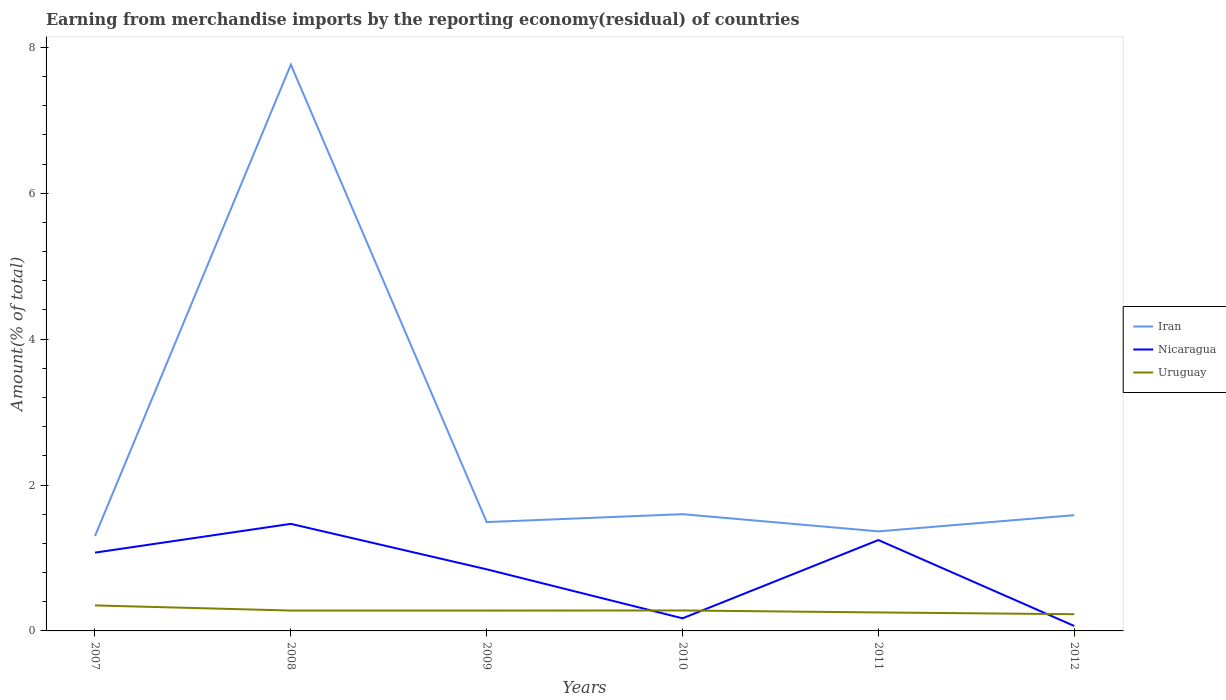Does the line corresponding to Uruguay intersect with the line corresponding to Iran?
Offer a terse response. No. Is the number of lines equal to the number of legend labels?
Your answer should be very brief. Yes. Across all years, what is the maximum percentage of amount earned from merchandise imports in Iran?
Your answer should be compact. 1.3. What is the total percentage of amount earned from merchandise imports in Iran in the graph?
Your answer should be very brief. -0.06. What is the difference between the highest and the second highest percentage of amount earned from merchandise imports in Iran?
Give a very brief answer. 6.46. What is the difference between the highest and the lowest percentage of amount earned from merchandise imports in Uruguay?
Provide a succinct answer. 4. How many lines are there?
Offer a terse response. 3. How many years are there in the graph?
Your answer should be very brief. 6. Does the graph contain any zero values?
Keep it short and to the point. No. Does the graph contain grids?
Provide a succinct answer. No. Where does the legend appear in the graph?
Your answer should be very brief. Center right. What is the title of the graph?
Offer a very short reply. Earning from merchandise imports by the reporting economy(residual) of countries. What is the label or title of the X-axis?
Your answer should be very brief. Years. What is the label or title of the Y-axis?
Make the answer very short. Amount(% of total). What is the Amount(% of total) in Iran in 2007?
Give a very brief answer. 1.3. What is the Amount(% of total) in Nicaragua in 2007?
Offer a very short reply. 1.07. What is the Amount(% of total) in Uruguay in 2007?
Ensure brevity in your answer.  0.35. What is the Amount(% of total) in Iran in 2008?
Make the answer very short. 7.76. What is the Amount(% of total) in Nicaragua in 2008?
Give a very brief answer. 1.47. What is the Amount(% of total) of Uruguay in 2008?
Ensure brevity in your answer.  0.28. What is the Amount(% of total) of Iran in 2009?
Ensure brevity in your answer.  1.49. What is the Amount(% of total) of Nicaragua in 2009?
Ensure brevity in your answer.  0.84. What is the Amount(% of total) in Uruguay in 2009?
Offer a very short reply. 0.28. What is the Amount(% of total) in Iran in 2010?
Your response must be concise. 1.6. What is the Amount(% of total) in Nicaragua in 2010?
Your answer should be compact. 0.17. What is the Amount(% of total) of Uruguay in 2010?
Offer a very short reply. 0.28. What is the Amount(% of total) of Iran in 2011?
Your response must be concise. 1.36. What is the Amount(% of total) in Nicaragua in 2011?
Ensure brevity in your answer.  1.25. What is the Amount(% of total) of Uruguay in 2011?
Your answer should be compact. 0.25. What is the Amount(% of total) in Iran in 2012?
Provide a short and direct response. 1.59. What is the Amount(% of total) in Nicaragua in 2012?
Offer a terse response. 0.07. What is the Amount(% of total) of Uruguay in 2012?
Ensure brevity in your answer.  0.23. Across all years, what is the maximum Amount(% of total) in Iran?
Keep it short and to the point. 7.76. Across all years, what is the maximum Amount(% of total) of Nicaragua?
Give a very brief answer. 1.47. Across all years, what is the maximum Amount(% of total) in Uruguay?
Provide a succinct answer. 0.35. Across all years, what is the minimum Amount(% of total) in Iran?
Your answer should be very brief. 1.3. Across all years, what is the minimum Amount(% of total) in Nicaragua?
Provide a short and direct response. 0.07. Across all years, what is the minimum Amount(% of total) of Uruguay?
Ensure brevity in your answer.  0.23. What is the total Amount(% of total) in Iran in the graph?
Offer a terse response. 15.11. What is the total Amount(% of total) in Nicaragua in the graph?
Provide a succinct answer. 4.87. What is the total Amount(% of total) of Uruguay in the graph?
Keep it short and to the point. 1.67. What is the difference between the Amount(% of total) of Iran in 2007 and that in 2008?
Offer a terse response. -6.46. What is the difference between the Amount(% of total) in Nicaragua in 2007 and that in 2008?
Provide a short and direct response. -0.39. What is the difference between the Amount(% of total) of Uruguay in 2007 and that in 2008?
Offer a terse response. 0.07. What is the difference between the Amount(% of total) of Iran in 2007 and that in 2009?
Offer a very short reply. -0.19. What is the difference between the Amount(% of total) in Nicaragua in 2007 and that in 2009?
Offer a terse response. 0.23. What is the difference between the Amount(% of total) in Uruguay in 2007 and that in 2009?
Make the answer very short. 0.07. What is the difference between the Amount(% of total) of Iran in 2007 and that in 2010?
Your answer should be very brief. -0.3. What is the difference between the Amount(% of total) in Nicaragua in 2007 and that in 2010?
Keep it short and to the point. 0.9. What is the difference between the Amount(% of total) of Uruguay in 2007 and that in 2010?
Provide a succinct answer. 0.07. What is the difference between the Amount(% of total) in Iran in 2007 and that in 2011?
Your response must be concise. -0.06. What is the difference between the Amount(% of total) in Nicaragua in 2007 and that in 2011?
Provide a short and direct response. -0.17. What is the difference between the Amount(% of total) of Uruguay in 2007 and that in 2011?
Offer a terse response. 0.1. What is the difference between the Amount(% of total) in Iran in 2007 and that in 2012?
Your answer should be very brief. -0.29. What is the difference between the Amount(% of total) of Nicaragua in 2007 and that in 2012?
Your answer should be very brief. 1.01. What is the difference between the Amount(% of total) in Uruguay in 2007 and that in 2012?
Ensure brevity in your answer.  0.12. What is the difference between the Amount(% of total) in Iran in 2008 and that in 2009?
Provide a succinct answer. 6.27. What is the difference between the Amount(% of total) in Nicaragua in 2008 and that in 2009?
Your answer should be very brief. 0.62. What is the difference between the Amount(% of total) in Uruguay in 2008 and that in 2009?
Give a very brief answer. 0. What is the difference between the Amount(% of total) in Iran in 2008 and that in 2010?
Offer a terse response. 6.16. What is the difference between the Amount(% of total) of Nicaragua in 2008 and that in 2010?
Offer a terse response. 1.29. What is the difference between the Amount(% of total) of Uruguay in 2008 and that in 2010?
Your answer should be very brief. -0. What is the difference between the Amount(% of total) in Iran in 2008 and that in 2011?
Provide a short and direct response. 6.4. What is the difference between the Amount(% of total) in Nicaragua in 2008 and that in 2011?
Provide a short and direct response. 0.22. What is the difference between the Amount(% of total) in Uruguay in 2008 and that in 2011?
Keep it short and to the point. 0.03. What is the difference between the Amount(% of total) in Iran in 2008 and that in 2012?
Offer a terse response. 6.18. What is the difference between the Amount(% of total) in Nicaragua in 2008 and that in 2012?
Make the answer very short. 1.4. What is the difference between the Amount(% of total) of Uruguay in 2008 and that in 2012?
Provide a short and direct response. 0.05. What is the difference between the Amount(% of total) of Iran in 2009 and that in 2010?
Keep it short and to the point. -0.11. What is the difference between the Amount(% of total) of Nicaragua in 2009 and that in 2010?
Your answer should be very brief. 0.67. What is the difference between the Amount(% of total) in Uruguay in 2009 and that in 2010?
Your answer should be compact. -0. What is the difference between the Amount(% of total) in Iran in 2009 and that in 2011?
Your answer should be compact. 0.13. What is the difference between the Amount(% of total) of Nicaragua in 2009 and that in 2011?
Offer a terse response. -0.4. What is the difference between the Amount(% of total) in Uruguay in 2009 and that in 2011?
Offer a very short reply. 0.03. What is the difference between the Amount(% of total) in Iran in 2009 and that in 2012?
Offer a terse response. -0.09. What is the difference between the Amount(% of total) of Nicaragua in 2009 and that in 2012?
Your answer should be very brief. 0.78. What is the difference between the Amount(% of total) in Uruguay in 2009 and that in 2012?
Ensure brevity in your answer.  0.05. What is the difference between the Amount(% of total) of Iran in 2010 and that in 2011?
Your answer should be compact. 0.24. What is the difference between the Amount(% of total) in Nicaragua in 2010 and that in 2011?
Ensure brevity in your answer.  -1.07. What is the difference between the Amount(% of total) of Uruguay in 2010 and that in 2011?
Keep it short and to the point. 0.03. What is the difference between the Amount(% of total) of Iran in 2010 and that in 2012?
Provide a succinct answer. 0.01. What is the difference between the Amount(% of total) in Nicaragua in 2010 and that in 2012?
Keep it short and to the point. 0.1. What is the difference between the Amount(% of total) in Uruguay in 2010 and that in 2012?
Your response must be concise. 0.05. What is the difference between the Amount(% of total) of Iran in 2011 and that in 2012?
Ensure brevity in your answer.  -0.22. What is the difference between the Amount(% of total) in Nicaragua in 2011 and that in 2012?
Make the answer very short. 1.18. What is the difference between the Amount(% of total) of Uruguay in 2011 and that in 2012?
Your response must be concise. 0.02. What is the difference between the Amount(% of total) in Iran in 2007 and the Amount(% of total) in Nicaragua in 2008?
Keep it short and to the point. -0.17. What is the difference between the Amount(% of total) in Iran in 2007 and the Amount(% of total) in Uruguay in 2008?
Give a very brief answer. 1.02. What is the difference between the Amount(% of total) in Nicaragua in 2007 and the Amount(% of total) in Uruguay in 2008?
Make the answer very short. 0.79. What is the difference between the Amount(% of total) in Iran in 2007 and the Amount(% of total) in Nicaragua in 2009?
Offer a terse response. 0.46. What is the difference between the Amount(% of total) in Iran in 2007 and the Amount(% of total) in Uruguay in 2009?
Offer a very short reply. 1.02. What is the difference between the Amount(% of total) in Nicaragua in 2007 and the Amount(% of total) in Uruguay in 2009?
Keep it short and to the point. 0.79. What is the difference between the Amount(% of total) of Iran in 2007 and the Amount(% of total) of Nicaragua in 2010?
Your response must be concise. 1.13. What is the difference between the Amount(% of total) in Iran in 2007 and the Amount(% of total) in Uruguay in 2010?
Make the answer very short. 1.02. What is the difference between the Amount(% of total) in Nicaragua in 2007 and the Amount(% of total) in Uruguay in 2010?
Provide a short and direct response. 0.79. What is the difference between the Amount(% of total) of Iran in 2007 and the Amount(% of total) of Nicaragua in 2011?
Your answer should be very brief. 0.06. What is the difference between the Amount(% of total) of Iran in 2007 and the Amount(% of total) of Uruguay in 2011?
Give a very brief answer. 1.05. What is the difference between the Amount(% of total) in Nicaragua in 2007 and the Amount(% of total) in Uruguay in 2011?
Offer a terse response. 0.82. What is the difference between the Amount(% of total) of Iran in 2007 and the Amount(% of total) of Nicaragua in 2012?
Offer a terse response. 1.23. What is the difference between the Amount(% of total) in Iran in 2007 and the Amount(% of total) in Uruguay in 2012?
Your answer should be very brief. 1.07. What is the difference between the Amount(% of total) in Nicaragua in 2007 and the Amount(% of total) in Uruguay in 2012?
Provide a succinct answer. 0.84. What is the difference between the Amount(% of total) of Iran in 2008 and the Amount(% of total) of Nicaragua in 2009?
Make the answer very short. 6.92. What is the difference between the Amount(% of total) of Iran in 2008 and the Amount(% of total) of Uruguay in 2009?
Provide a succinct answer. 7.48. What is the difference between the Amount(% of total) in Nicaragua in 2008 and the Amount(% of total) in Uruguay in 2009?
Offer a terse response. 1.19. What is the difference between the Amount(% of total) of Iran in 2008 and the Amount(% of total) of Nicaragua in 2010?
Make the answer very short. 7.59. What is the difference between the Amount(% of total) of Iran in 2008 and the Amount(% of total) of Uruguay in 2010?
Your response must be concise. 7.48. What is the difference between the Amount(% of total) of Nicaragua in 2008 and the Amount(% of total) of Uruguay in 2010?
Ensure brevity in your answer.  1.19. What is the difference between the Amount(% of total) in Iran in 2008 and the Amount(% of total) in Nicaragua in 2011?
Provide a succinct answer. 6.52. What is the difference between the Amount(% of total) in Iran in 2008 and the Amount(% of total) in Uruguay in 2011?
Offer a very short reply. 7.51. What is the difference between the Amount(% of total) of Nicaragua in 2008 and the Amount(% of total) of Uruguay in 2011?
Keep it short and to the point. 1.21. What is the difference between the Amount(% of total) in Iran in 2008 and the Amount(% of total) in Nicaragua in 2012?
Your response must be concise. 7.69. What is the difference between the Amount(% of total) of Iran in 2008 and the Amount(% of total) of Uruguay in 2012?
Make the answer very short. 7.53. What is the difference between the Amount(% of total) of Nicaragua in 2008 and the Amount(% of total) of Uruguay in 2012?
Make the answer very short. 1.24. What is the difference between the Amount(% of total) of Iran in 2009 and the Amount(% of total) of Nicaragua in 2010?
Keep it short and to the point. 1.32. What is the difference between the Amount(% of total) in Iran in 2009 and the Amount(% of total) in Uruguay in 2010?
Your response must be concise. 1.21. What is the difference between the Amount(% of total) in Nicaragua in 2009 and the Amount(% of total) in Uruguay in 2010?
Keep it short and to the point. 0.56. What is the difference between the Amount(% of total) in Iran in 2009 and the Amount(% of total) in Nicaragua in 2011?
Provide a short and direct response. 0.25. What is the difference between the Amount(% of total) in Iran in 2009 and the Amount(% of total) in Uruguay in 2011?
Your answer should be compact. 1.24. What is the difference between the Amount(% of total) of Nicaragua in 2009 and the Amount(% of total) of Uruguay in 2011?
Give a very brief answer. 0.59. What is the difference between the Amount(% of total) in Iran in 2009 and the Amount(% of total) in Nicaragua in 2012?
Your answer should be very brief. 1.42. What is the difference between the Amount(% of total) in Iran in 2009 and the Amount(% of total) in Uruguay in 2012?
Offer a terse response. 1.26. What is the difference between the Amount(% of total) of Nicaragua in 2009 and the Amount(% of total) of Uruguay in 2012?
Your answer should be very brief. 0.62. What is the difference between the Amount(% of total) in Iran in 2010 and the Amount(% of total) in Nicaragua in 2011?
Keep it short and to the point. 0.35. What is the difference between the Amount(% of total) in Iran in 2010 and the Amount(% of total) in Uruguay in 2011?
Offer a very short reply. 1.35. What is the difference between the Amount(% of total) of Nicaragua in 2010 and the Amount(% of total) of Uruguay in 2011?
Keep it short and to the point. -0.08. What is the difference between the Amount(% of total) in Iran in 2010 and the Amount(% of total) in Nicaragua in 2012?
Provide a succinct answer. 1.53. What is the difference between the Amount(% of total) in Iran in 2010 and the Amount(% of total) in Uruguay in 2012?
Your answer should be compact. 1.37. What is the difference between the Amount(% of total) in Nicaragua in 2010 and the Amount(% of total) in Uruguay in 2012?
Your answer should be very brief. -0.06. What is the difference between the Amount(% of total) in Iran in 2011 and the Amount(% of total) in Nicaragua in 2012?
Give a very brief answer. 1.3. What is the difference between the Amount(% of total) in Iran in 2011 and the Amount(% of total) in Uruguay in 2012?
Your answer should be very brief. 1.14. What is the difference between the Amount(% of total) in Nicaragua in 2011 and the Amount(% of total) in Uruguay in 2012?
Offer a terse response. 1.02. What is the average Amount(% of total) of Iran per year?
Make the answer very short. 2.52. What is the average Amount(% of total) of Nicaragua per year?
Your response must be concise. 0.81. What is the average Amount(% of total) of Uruguay per year?
Make the answer very short. 0.28. In the year 2007, what is the difference between the Amount(% of total) of Iran and Amount(% of total) of Nicaragua?
Make the answer very short. 0.23. In the year 2007, what is the difference between the Amount(% of total) of Iran and Amount(% of total) of Uruguay?
Ensure brevity in your answer.  0.95. In the year 2007, what is the difference between the Amount(% of total) of Nicaragua and Amount(% of total) of Uruguay?
Give a very brief answer. 0.72. In the year 2008, what is the difference between the Amount(% of total) in Iran and Amount(% of total) in Nicaragua?
Your answer should be compact. 6.29. In the year 2008, what is the difference between the Amount(% of total) in Iran and Amount(% of total) in Uruguay?
Make the answer very short. 7.48. In the year 2008, what is the difference between the Amount(% of total) of Nicaragua and Amount(% of total) of Uruguay?
Your response must be concise. 1.19. In the year 2009, what is the difference between the Amount(% of total) of Iran and Amount(% of total) of Nicaragua?
Your answer should be very brief. 0.65. In the year 2009, what is the difference between the Amount(% of total) of Iran and Amount(% of total) of Uruguay?
Keep it short and to the point. 1.21. In the year 2009, what is the difference between the Amount(% of total) of Nicaragua and Amount(% of total) of Uruguay?
Provide a succinct answer. 0.57. In the year 2010, what is the difference between the Amount(% of total) of Iran and Amount(% of total) of Nicaragua?
Offer a terse response. 1.43. In the year 2010, what is the difference between the Amount(% of total) in Iran and Amount(% of total) in Uruguay?
Make the answer very short. 1.32. In the year 2010, what is the difference between the Amount(% of total) in Nicaragua and Amount(% of total) in Uruguay?
Offer a very short reply. -0.11. In the year 2011, what is the difference between the Amount(% of total) in Iran and Amount(% of total) in Nicaragua?
Offer a terse response. 0.12. In the year 2011, what is the difference between the Amount(% of total) in Iran and Amount(% of total) in Uruguay?
Provide a short and direct response. 1.11. In the year 2012, what is the difference between the Amount(% of total) of Iran and Amount(% of total) of Nicaragua?
Offer a very short reply. 1.52. In the year 2012, what is the difference between the Amount(% of total) of Iran and Amount(% of total) of Uruguay?
Your response must be concise. 1.36. In the year 2012, what is the difference between the Amount(% of total) of Nicaragua and Amount(% of total) of Uruguay?
Keep it short and to the point. -0.16. What is the ratio of the Amount(% of total) in Iran in 2007 to that in 2008?
Your answer should be very brief. 0.17. What is the ratio of the Amount(% of total) of Nicaragua in 2007 to that in 2008?
Your response must be concise. 0.73. What is the ratio of the Amount(% of total) of Uruguay in 2007 to that in 2008?
Ensure brevity in your answer.  1.25. What is the ratio of the Amount(% of total) in Iran in 2007 to that in 2009?
Make the answer very short. 0.87. What is the ratio of the Amount(% of total) in Nicaragua in 2007 to that in 2009?
Give a very brief answer. 1.27. What is the ratio of the Amount(% of total) of Uruguay in 2007 to that in 2009?
Offer a terse response. 1.25. What is the ratio of the Amount(% of total) of Iran in 2007 to that in 2010?
Provide a short and direct response. 0.81. What is the ratio of the Amount(% of total) in Nicaragua in 2007 to that in 2010?
Provide a succinct answer. 6.21. What is the ratio of the Amount(% of total) in Uruguay in 2007 to that in 2010?
Your response must be concise. 1.25. What is the ratio of the Amount(% of total) in Iran in 2007 to that in 2011?
Your response must be concise. 0.95. What is the ratio of the Amount(% of total) of Nicaragua in 2007 to that in 2011?
Ensure brevity in your answer.  0.86. What is the ratio of the Amount(% of total) in Uruguay in 2007 to that in 2011?
Ensure brevity in your answer.  1.38. What is the ratio of the Amount(% of total) in Iran in 2007 to that in 2012?
Your answer should be compact. 0.82. What is the ratio of the Amount(% of total) in Nicaragua in 2007 to that in 2012?
Ensure brevity in your answer.  15.83. What is the ratio of the Amount(% of total) of Uruguay in 2007 to that in 2012?
Offer a very short reply. 1.53. What is the ratio of the Amount(% of total) of Iran in 2008 to that in 2009?
Your answer should be compact. 5.2. What is the ratio of the Amount(% of total) of Nicaragua in 2008 to that in 2009?
Your response must be concise. 1.74. What is the ratio of the Amount(% of total) in Uruguay in 2008 to that in 2009?
Your answer should be very brief. 1. What is the ratio of the Amount(% of total) in Iran in 2008 to that in 2010?
Make the answer very short. 4.85. What is the ratio of the Amount(% of total) of Nicaragua in 2008 to that in 2010?
Provide a short and direct response. 8.49. What is the ratio of the Amount(% of total) in Uruguay in 2008 to that in 2010?
Give a very brief answer. 1. What is the ratio of the Amount(% of total) of Iran in 2008 to that in 2011?
Provide a succinct answer. 5.69. What is the ratio of the Amount(% of total) in Nicaragua in 2008 to that in 2011?
Ensure brevity in your answer.  1.18. What is the ratio of the Amount(% of total) of Uruguay in 2008 to that in 2011?
Offer a terse response. 1.1. What is the ratio of the Amount(% of total) in Iran in 2008 to that in 2012?
Offer a terse response. 4.89. What is the ratio of the Amount(% of total) of Nicaragua in 2008 to that in 2012?
Offer a terse response. 21.64. What is the ratio of the Amount(% of total) of Uruguay in 2008 to that in 2012?
Make the answer very short. 1.22. What is the ratio of the Amount(% of total) of Iran in 2009 to that in 2010?
Give a very brief answer. 0.93. What is the ratio of the Amount(% of total) of Nicaragua in 2009 to that in 2010?
Offer a terse response. 4.89. What is the ratio of the Amount(% of total) of Iran in 2009 to that in 2011?
Your answer should be very brief. 1.09. What is the ratio of the Amount(% of total) in Nicaragua in 2009 to that in 2011?
Ensure brevity in your answer.  0.68. What is the ratio of the Amount(% of total) of Uruguay in 2009 to that in 2011?
Provide a short and direct response. 1.1. What is the ratio of the Amount(% of total) in Iran in 2009 to that in 2012?
Keep it short and to the point. 0.94. What is the ratio of the Amount(% of total) of Nicaragua in 2009 to that in 2012?
Make the answer very short. 12.45. What is the ratio of the Amount(% of total) in Uruguay in 2009 to that in 2012?
Offer a terse response. 1.22. What is the ratio of the Amount(% of total) of Iran in 2010 to that in 2011?
Keep it short and to the point. 1.17. What is the ratio of the Amount(% of total) of Nicaragua in 2010 to that in 2011?
Provide a short and direct response. 0.14. What is the ratio of the Amount(% of total) in Uruguay in 2010 to that in 2011?
Provide a succinct answer. 1.11. What is the ratio of the Amount(% of total) in Iran in 2010 to that in 2012?
Provide a succinct answer. 1.01. What is the ratio of the Amount(% of total) of Nicaragua in 2010 to that in 2012?
Offer a very short reply. 2.55. What is the ratio of the Amount(% of total) of Uruguay in 2010 to that in 2012?
Offer a terse response. 1.22. What is the ratio of the Amount(% of total) of Iran in 2011 to that in 2012?
Provide a short and direct response. 0.86. What is the ratio of the Amount(% of total) of Nicaragua in 2011 to that in 2012?
Keep it short and to the point. 18.37. What is the ratio of the Amount(% of total) of Uruguay in 2011 to that in 2012?
Your answer should be very brief. 1.11. What is the difference between the highest and the second highest Amount(% of total) in Iran?
Offer a terse response. 6.16. What is the difference between the highest and the second highest Amount(% of total) of Nicaragua?
Your answer should be very brief. 0.22. What is the difference between the highest and the second highest Amount(% of total) in Uruguay?
Keep it short and to the point. 0.07. What is the difference between the highest and the lowest Amount(% of total) in Iran?
Provide a short and direct response. 6.46. What is the difference between the highest and the lowest Amount(% of total) of Nicaragua?
Keep it short and to the point. 1.4. What is the difference between the highest and the lowest Amount(% of total) of Uruguay?
Provide a short and direct response. 0.12. 